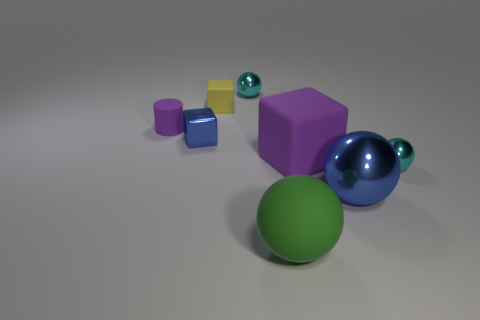Subtract all purple blocks. How many cyan balls are left? 2 Subtract all big blue metallic spheres. How many spheres are left? 3 Subtract all green spheres. How many spheres are left? 3 Subtract 2 balls. How many balls are left? 2 Add 1 purple cylinders. How many objects exist? 9 Subtract all cylinders. How many objects are left? 7 Subtract all yellow balls. Subtract all red cylinders. How many balls are left? 4 Subtract 0 red balls. How many objects are left? 8 Subtract all large blue metallic objects. Subtract all large rubber balls. How many objects are left? 6 Add 6 small blue cubes. How many small blue cubes are left? 7 